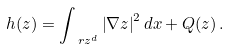Convert formula to latex. <formula><loc_0><loc_0><loc_500><loc_500>h ( z ) = \int _ { \ r z ^ { d } } \left | \nabla z \right | ^ { 2 } d x + Q ( z ) \, .</formula> 